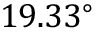Convert formula to latex. <formula><loc_0><loc_0><loc_500><loc_500>1 9 . 3 3 ^ { \circ }</formula> 